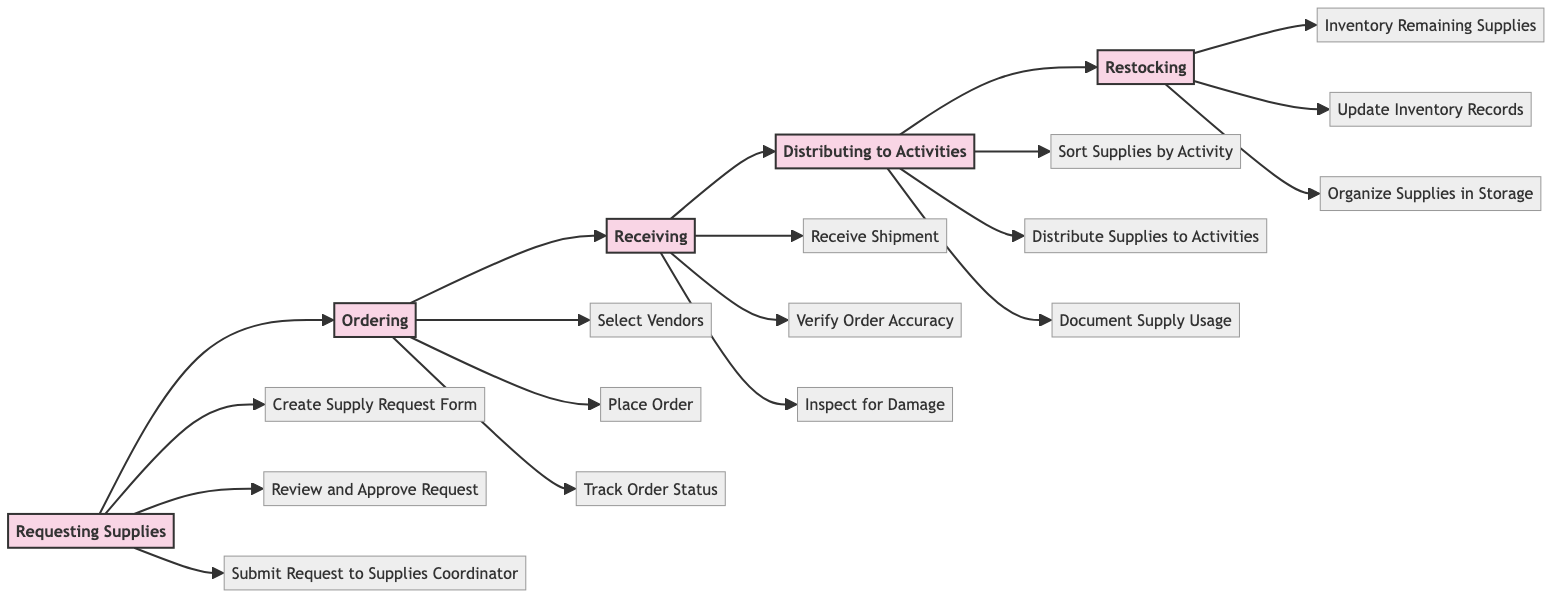What is the first stage in the workflow? The first stage in the workflow is "Requesting Supplies." This is identified directly from the leftmost box in the diagram, indicating the starting point of the process.
Answer: Requesting Supplies How many stages are there in the workflow? The diagram contains five distinct stages: Requesting Supplies, Ordering, Receiving, Distributing to Activities, and Restocking. By counting each labeled stage in the flowchart, we come to the total.
Answer: 5 Who is responsible for reviewing and approving requests? The responsibility for reviewing and approving requests falls on the "Art Therapist," as indicated by the action connected to the "Requesting Supplies" stage, specifically labeled in the diagram.
Answer: Art Therapist What comes immediately after receiving shipments? After receiving shipments, the next action is to "Verify Order Accuracy," which is shown as the first action under the "Receiving" stage in the flowchart.
Answer: Verify Order Accuracy How many actions are there under the "Distributing to Activities" stage? There are three actions listed under the "Distributing to Activities" stage, specifically: "Sort Supplies by Activity," "Distribute Supplies to Activities," and "Document Supply Usage." This is verified by counting the actions linked to that stage.
Answer: 3 Which stage includes organizing supplies in storage? The stage that includes the task of organizing supplies in storage is "Restocking." This can be found at the far right in the flowchart, highlighting the final action in the workflow.
Answer: Restocking What action happens right before restocking? The action that occurs right before restocking is "Document Supply Usage," which is the last action in the "Distributing to Activities" stage, leading directly to the restocking process.
Answer: Document Supply Usage Which roles are involved in the supply ordering process? The role involved in the supply ordering process is solely the "Supplies Coordinator," as indicated by all actions related to ordering supplies listed under the "Ordering" stage.
Answer: Supplies Coordinator Which action must occur before the request is submitted to the Supplies Coordinator? The action that must occur before submitting the request to the Supplies Coordinator is "Review and Approve Request," as shown in the diagram as a prerequisite action in the "Requesting Supplies" stage.
Answer: Review and Approve Request 